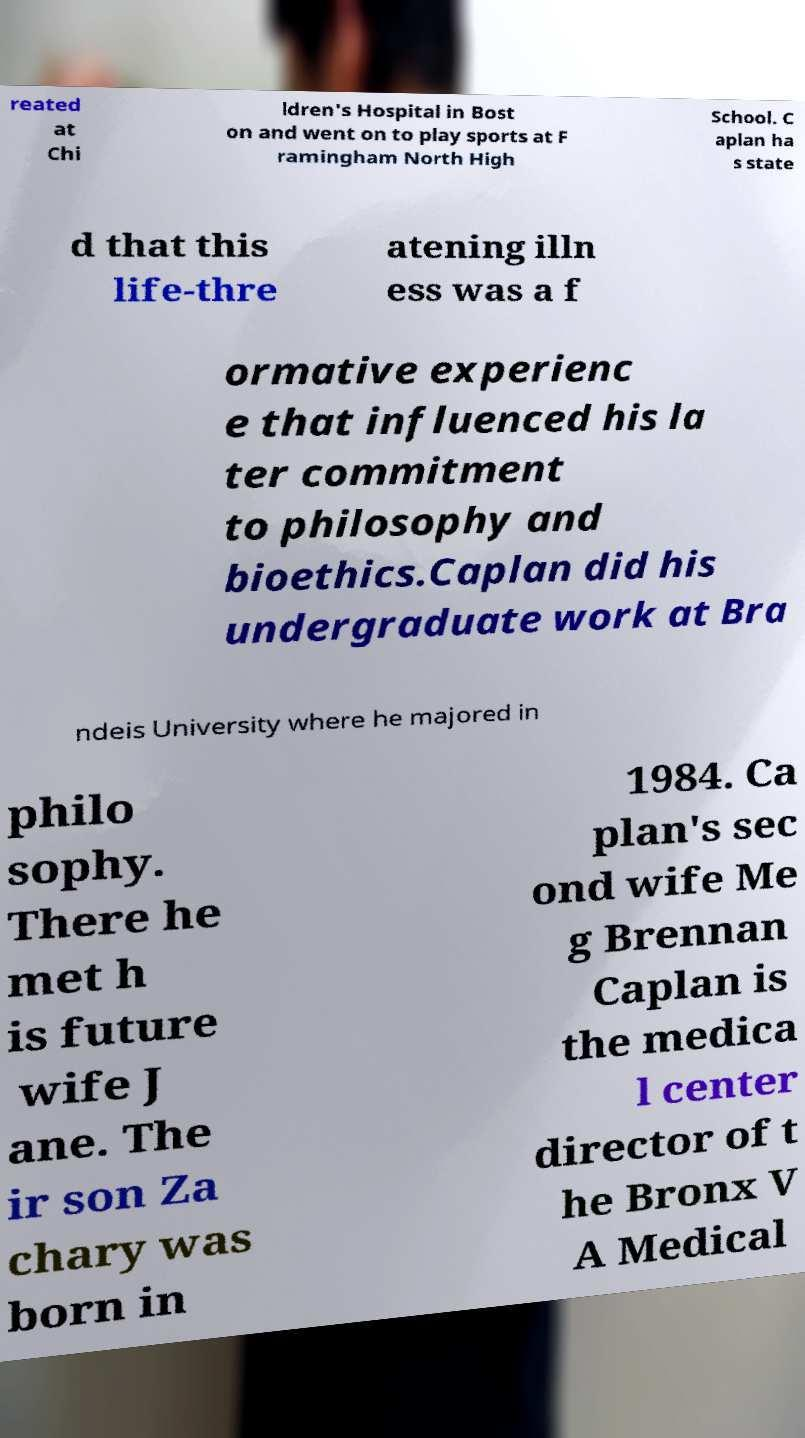There's text embedded in this image that I need extracted. Can you transcribe it verbatim? reated at Chi ldren's Hospital in Bost on and went on to play sports at F ramingham North High School. C aplan ha s state d that this life-thre atening illn ess was a f ormative experienc e that influenced his la ter commitment to philosophy and bioethics.Caplan did his undergraduate work at Bra ndeis University where he majored in philo sophy. There he met h is future wife J ane. The ir son Za chary was born in 1984. Ca plan's sec ond wife Me g Brennan Caplan is the medica l center director of t he Bronx V A Medical 